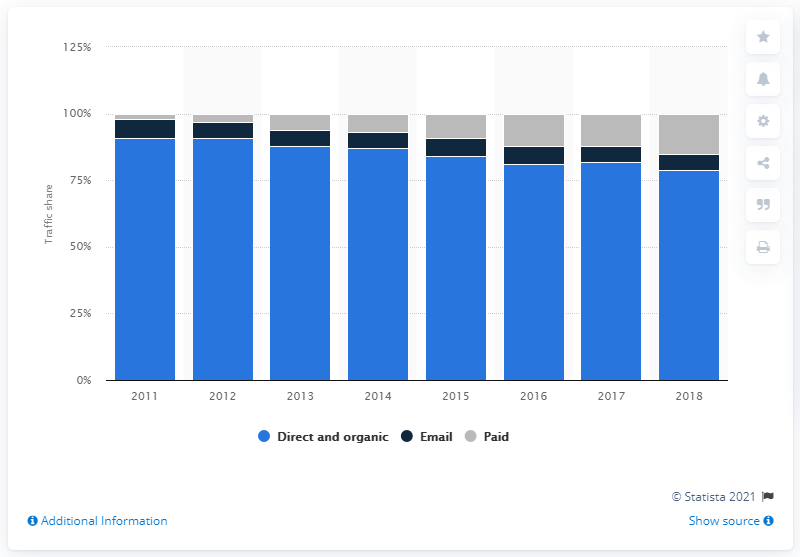Draw attention to some important aspects in this diagram. During the most recent period, organic traffic accounted for approximately 79% of all visits to Etsy. 